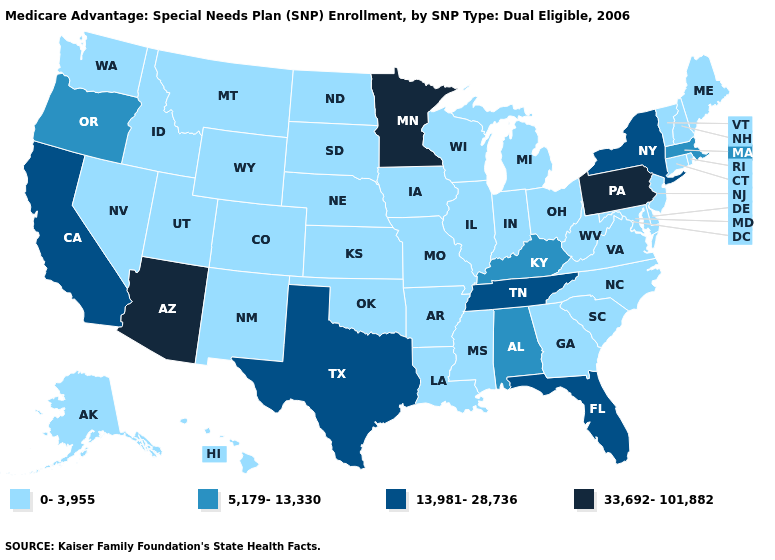How many symbols are there in the legend?
Short answer required. 4. Does Oregon have the lowest value in the USA?
Quick response, please. No. Does the first symbol in the legend represent the smallest category?
Concise answer only. Yes. Does the first symbol in the legend represent the smallest category?
Quick response, please. Yes. Name the states that have a value in the range 33,692-101,882?
Answer briefly. Arizona, Minnesota, Pennsylvania. Name the states that have a value in the range 0-3,955?
Be succinct. Alaska, Arkansas, Colorado, Connecticut, Delaware, Georgia, Hawaii, Iowa, Idaho, Illinois, Indiana, Kansas, Louisiana, Maryland, Maine, Michigan, Missouri, Mississippi, Montana, North Carolina, North Dakota, Nebraska, New Hampshire, New Jersey, New Mexico, Nevada, Ohio, Oklahoma, Rhode Island, South Carolina, South Dakota, Utah, Virginia, Vermont, Washington, Wisconsin, West Virginia, Wyoming. Which states have the lowest value in the USA?
Give a very brief answer. Alaska, Arkansas, Colorado, Connecticut, Delaware, Georgia, Hawaii, Iowa, Idaho, Illinois, Indiana, Kansas, Louisiana, Maryland, Maine, Michigan, Missouri, Mississippi, Montana, North Carolina, North Dakota, Nebraska, New Hampshire, New Jersey, New Mexico, Nevada, Ohio, Oklahoma, Rhode Island, South Carolina, South Dakota, Utah, Virginia, Vermont, Washington, Wisconsin, West Virginia, Wyoming. Which states hav the highest value in the MidWest?
Be succinct. Minnesota. Does Missouri have the highest value in the MidWest?
Be succinct. No. What is the value of Texas?
Be succinct. 13,981-28,736. Which states hav the highest value in the Northeast?
Write a very short answer. Pennsylvania. Does Michigan have the lowest value in the USA?
Concise answer only. Yes. Among the states that border Tennessee , which have the lowest value?
Keep it brief. Arkansas, Georgia, Missouri, Mississippi, North Carolina, Virginia. Name the states that have a value in the range 5,179-13,330?
Keep it brief. Alabama, Kentucky, Massachusetts, Oregon. Name the states that have a value in the range 5,179-13,330?
Give a very brief answer. Alabama, Kentucky, Massachusetts, Oregon. 